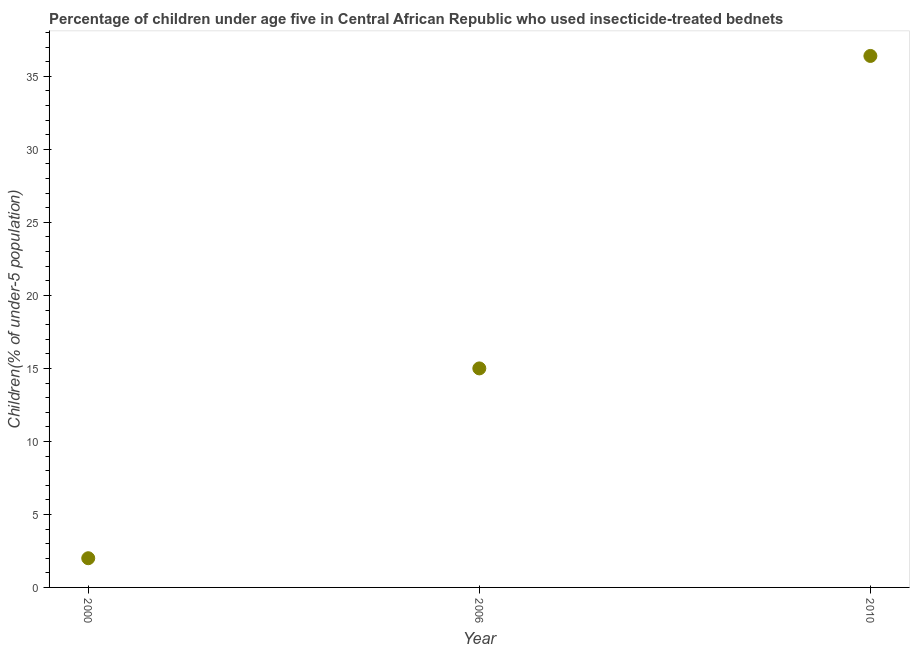What is the percentage of children who use of insecticide-treated bed nets in 2010?
Make the answer very short. 36.4. Across all years, what is the maximum percentage of children who use of insecticide-treated bed nets?
Your answer should be compact. 36.4. What is the sum of the percentage of children who use of insecticide-treated bed nets?
Your response must be concise. 53.4. What is the difference between the percentage of children who use of insecticide-treated bed nets in 2000 and 2010?
Ensure brevity in your answer.  -34.4. What is the average percentage of children who use of insecticide-treated bed nets per year?
Your response must be concise. 17.8. What is the median percentage of children who use of insecticide-treated bed nets?
Your answer should be compact. 15. What is the ratio of the percentage of children who use of insecticide-treated bed nets in 2000 to that in 2006?
Keep it short and to the point. 0.13. Is the difference between the percentage of children who use of insecticide-treated bed nets in 2006 and 2010 greater than the difference between any two years?
Provide a short and direct response. No. What is the difference between the highest and the second highest percentage of children who use of insecticide-treated bed nets?
Your answer should be compact. 21.4. Is the sum of the percentage of children who use of insecticide-treated bed nets in 2000 and 2010 greater than the maximum percentage of children who use of insecticide-treated bed nets across all years?
Your answer should be very brief. Yes. What is the difference between the highest and the lowest percentage of children who use of insecticide-treated bed nets?
Ensure brevity in your answer.  34.4. How many dotlines are there?
Your answer should be very brief. 1. How many years are there in the graph?
Offer a very short reply. 3. Are the values on the major ticks of Y-axis written in scientific E-notation?
Provide a short and direct response. No. What is the title of the graph?
Ensure brevity in your answer.  Percentage of children under age five in Central African Republic who used insecticide-treated bednets. What is the label or title of the Y-axis?
Your answer should be compact. Children(% of under-5 population). What is the Children(% of under-5 population) in 2010?
Offer a terse response. 36.4. What is the difference between the Children(% of under-5 population) in 2000 and 2010?
Give a very brief answer. -34.4. What is the difference between the Children(% of under-5 population) in 2006 and 2010?
Ensure brevity in your answer.  -21.4. What is the ratio of the Children(% of under-5 population) in 2000 to that in 2006?
Keep it short and to the point. 0.13. What is the ratio of the Children(% of under-5 population) in 2000 to that in 2010?
Your answer should be very brief. 0.06. What is the ratio of the Children(% of under-5 population) in 2006 to that in 2010?
Keep it short and to the point. 0.41. 